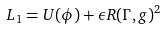Convert formula to latex. <formula><loc_0><loc_0><loc_500><loc_500>L _ { 1 } = U ( \phi ) + \epsilon R ( \Gamma , g ) ^ { 2 }</formula> 